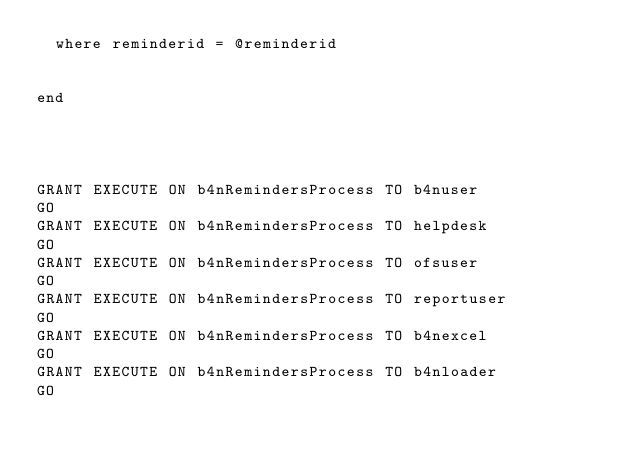Convert code to text. <code><loc_0><loc_0><loc_500><loc_500><_SQL_>	where reminderid = @reminderid
	

end




GRANT EXECUTE ON b4nRemindersProcess TO b4nuser
GO
GRANT EXECUTE ON b4nRemindersProcess TO helpdesk
GO
GRANT EXECUTE ON b4nRemindersProcess TO ofsuser
GO
GRANT EXECUTE ON b4nRemindersProcess TO reportuser
GO
GRANT EXECUTE ON b4nRemindersProcess TO b4nexcel
GO
GRANT EXECUTE ON b4nRemindersProcess TO b4nloader
GO
</code> 